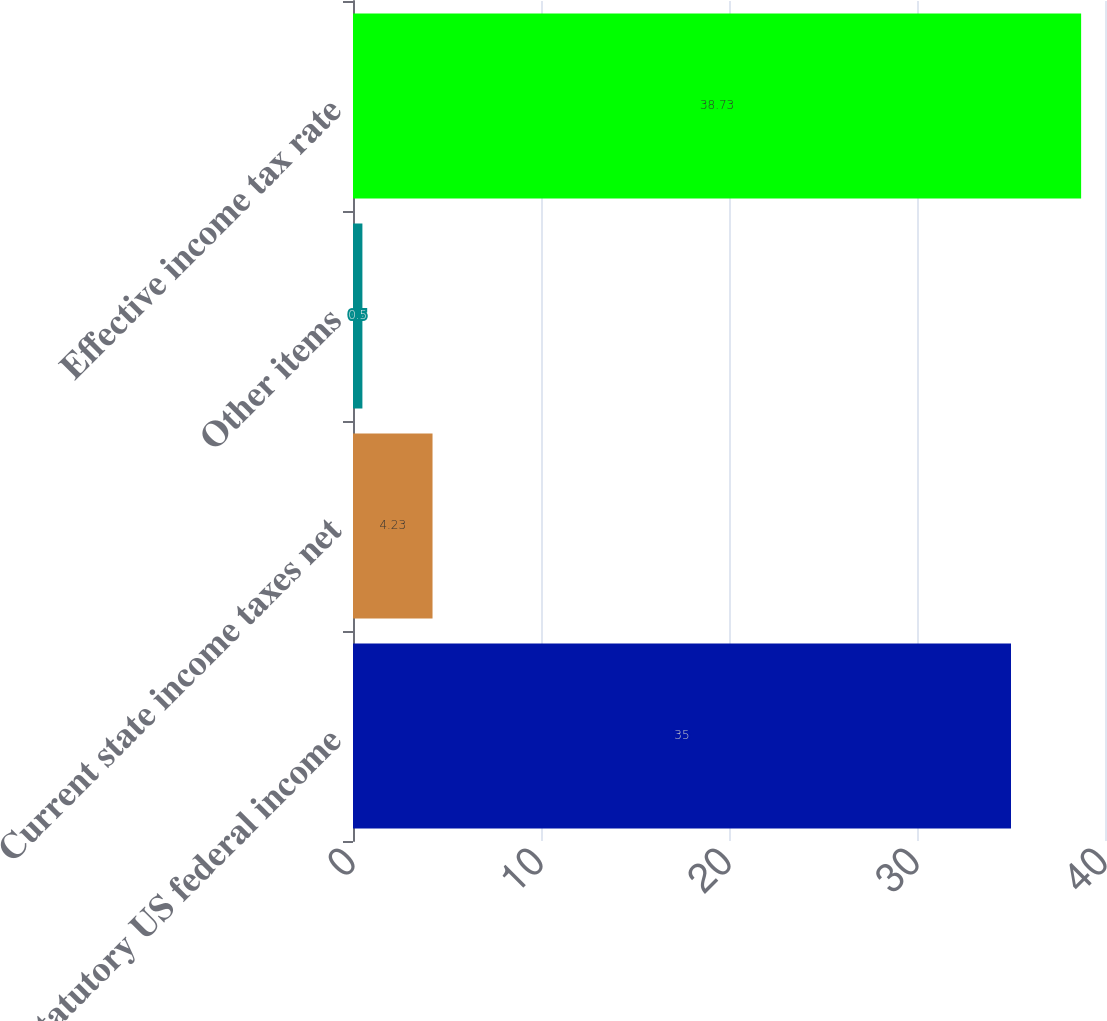Convert chart. <chart><loc_0><loc_0><loc_500><loc_500><bar_chart><fcel>Statutory US federal income<fcel>Current state income taxes net<fcel>Other items<fcel>Effective income tax rate<nl><fcel>35<fcel>4.23<fcel>0.5<fcel>38.73<nl></chart> 